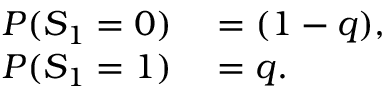<formula> <loc_0><loc_0><loc_500><loc_500>\begin{array} { r l } { P ( S _ { 1 } = 0 ) } & = ( 1 - q ) , } \\ { P ( S _ { 1 } = 1 ) } & = q . } \end{array}</formula> 